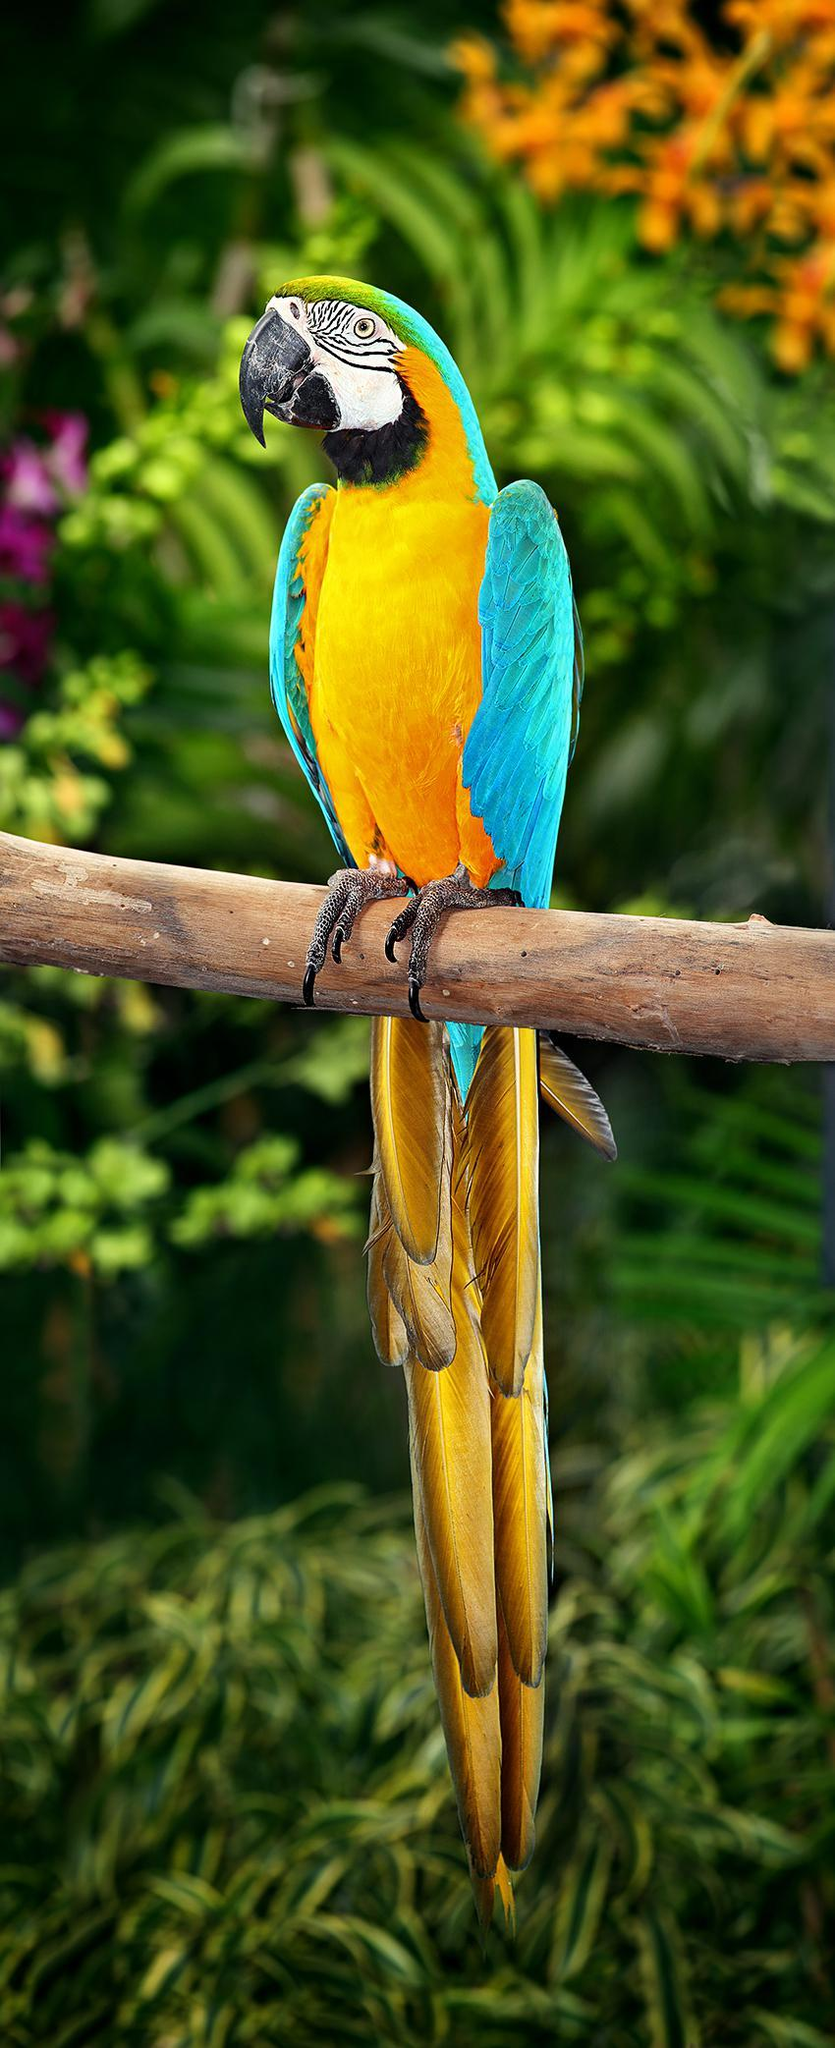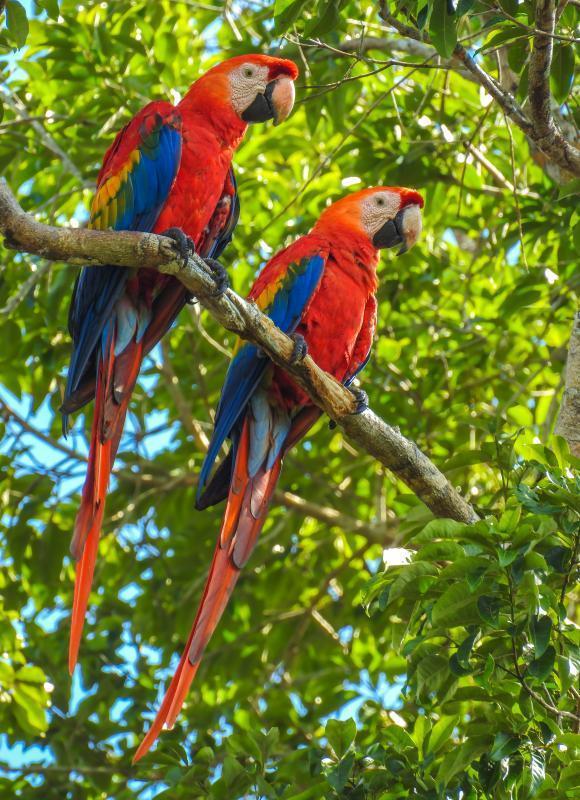The first image is the image on the left, the second image is the image on the right. For the images shown, is this caption "There are at least four birds in the image on the right." true? Answer yes or no. No. 